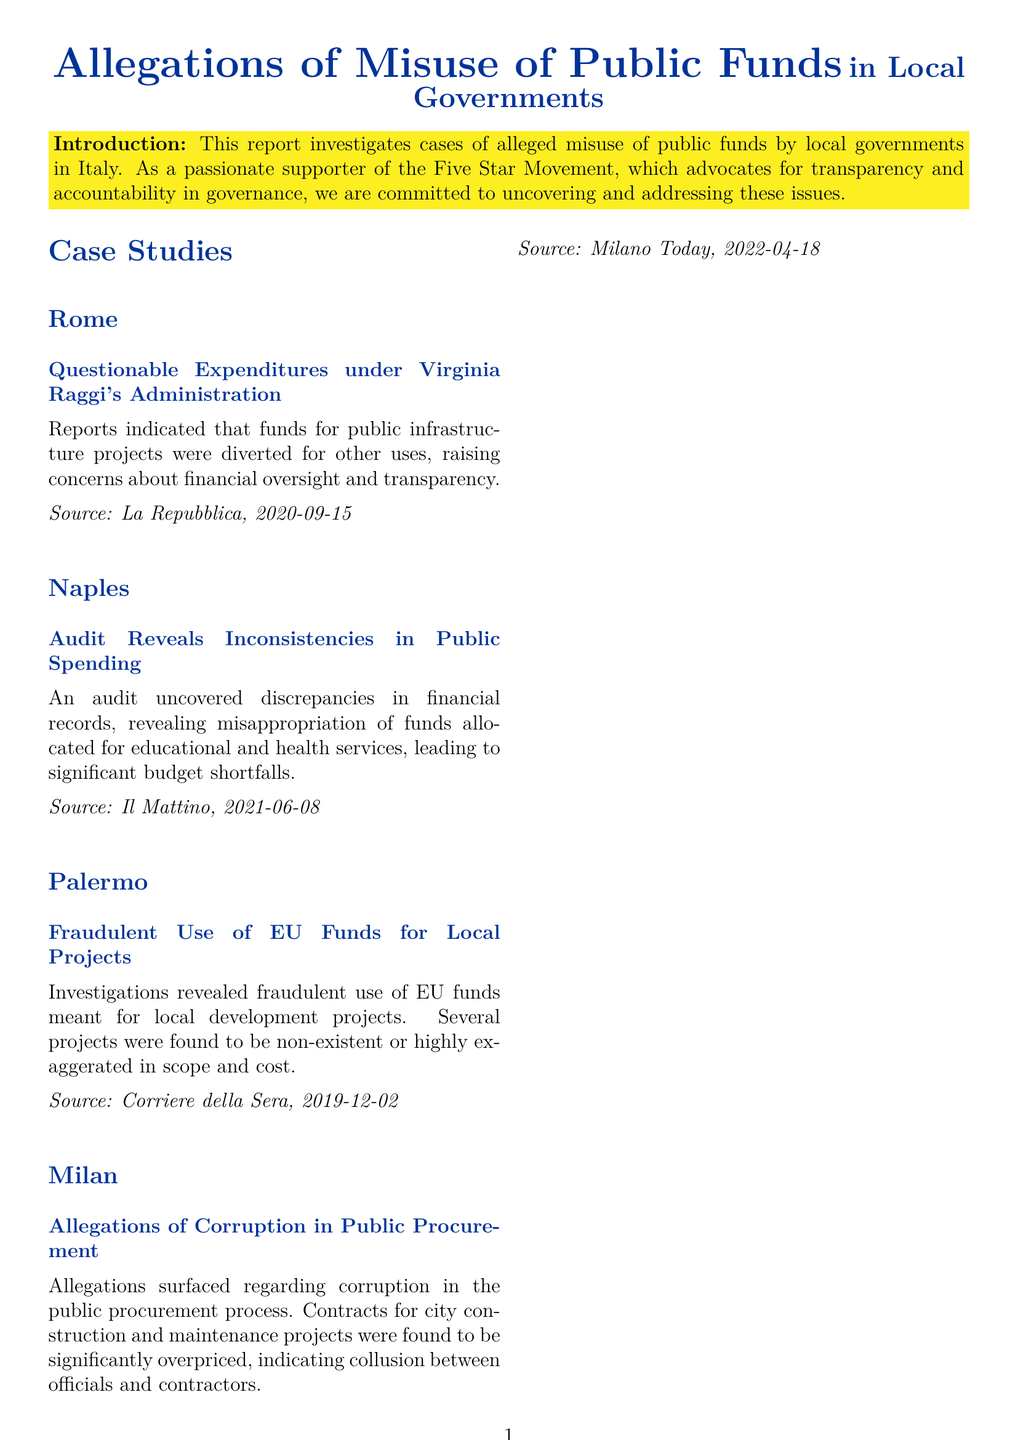What city faced questionable expenditures under Virginia Raggi's administration? The document specifies that the case regarding questionable expenditures occurred in Rome during Virginia Raggi's administration.
Answer: Rome Which local government's audit revealed inconsistencies in public spending? According to the document, the audit that uncovered discrepancies was related to Naples.
Answer: Naples What was the nature of fraudulent activity in Palermo? The document mentions that in Palermo, there was fraudulent use of EU funds for local development projects.
Answer: EU funds What issue was highlighted regarding public procurement in Milan? The document outlines that there were allegations of corruption in the public procurement process in Milan.
Answer: Corruption What date was the report about Naples published? The publication date for the audit revealed in Naples is stated as June 8, 2021.
Answer: 2021-06-08 What does the report suggest as a necessary response to the cases discussed? The conclusion in the document lists stronger financial oversight as a necessary response.
Answer: Stronger financial oversight How many case studies are presented in the report? The document presents four specific case studies related to misuse of public funds.
Answer: Four What is the main focus of the Five Star Movement as mentioned in the report? The document emphasizes that the Five Star Movement advocates for transparency, accountability, and integrity in governance.
Answer: Transparency What type of document is this? The report is categorized as an incident report investigating allegations of misuse of public funds in local governments.
Answer: Incident report 